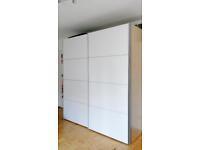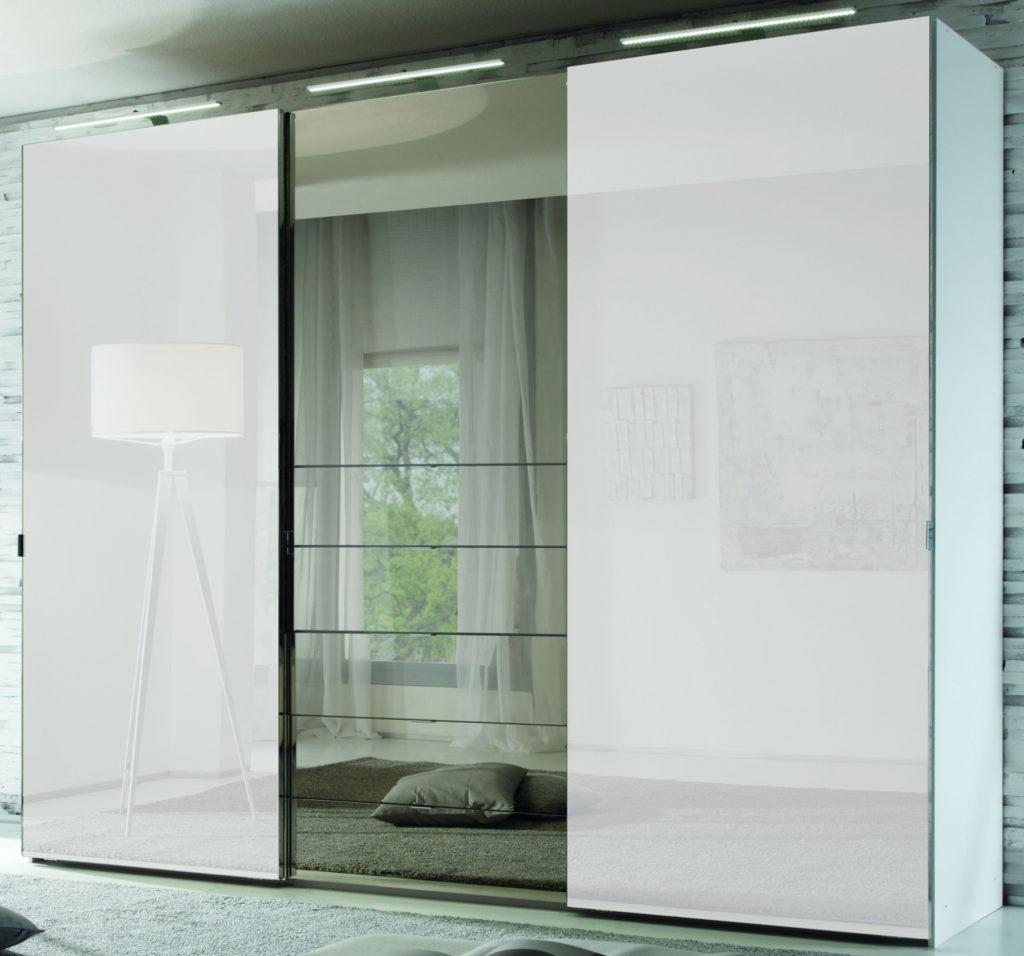The first image is the image on the left, the second image is the image on the right. Given the left and right images, does the statement "There is a two door closet closed with the front being white with light line to create eight rectangles." hold true? Answer yes or no. Yes. The first image is the image on the left, the second image is the image on the right. Considering the images on both sides, is "One door is mirrored." valid? Answer yes or no. Yes. 